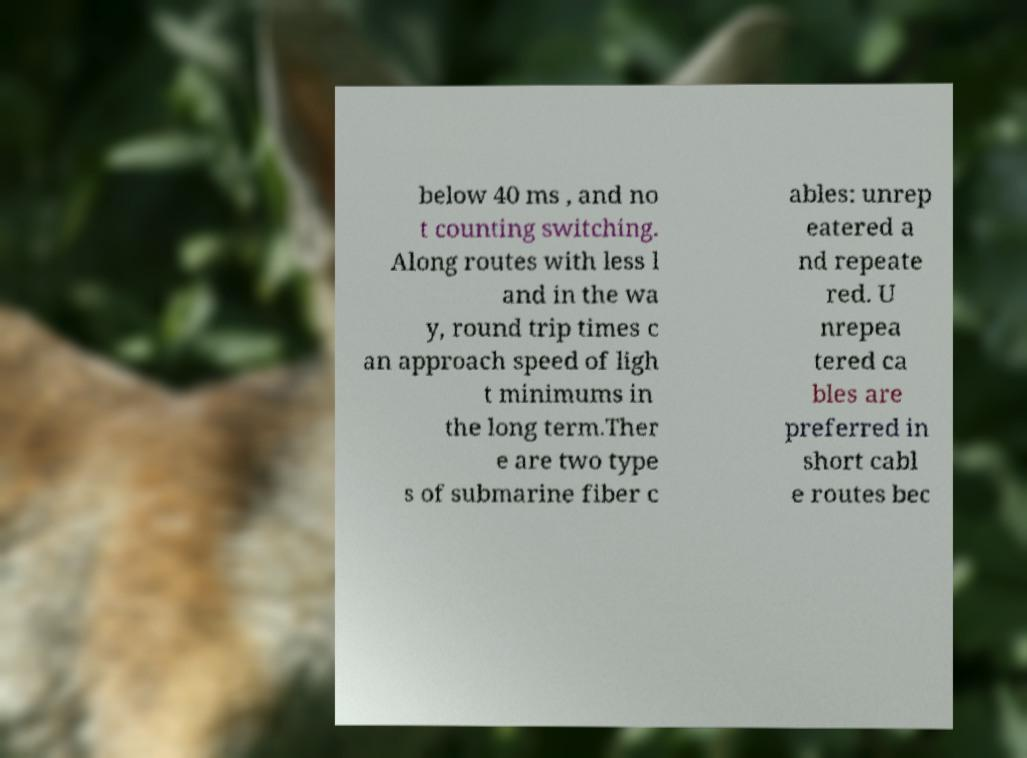Please identify and transcribe the text found in this image. below 40 ms , and no t counting switching. Along routes with less l and in the wa y, round trip times c an approach speed of ligh t minimums in the long term.Ther e are two type s of submarine fiber c ables: unrep eatered a nd repeate red. U nrepea tered ca bles are preferred in short cabl e routes bec 